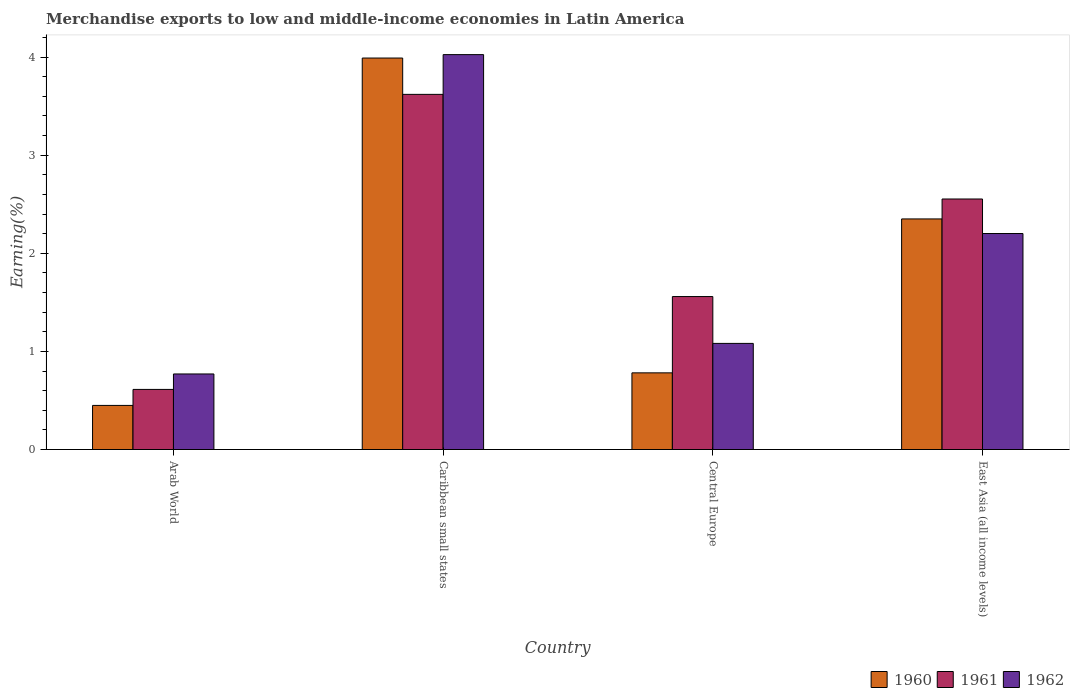How many groups of bars are there?
Keep it short and to the point. 4. Are the number of bars on each tick of the X-axis equal?
Provide a short and direct response. Yes. How many bars are there on the 3rd tick from the right?
Provide a short and direct response. 3. What is the label of the 2nd group of bars from the left?
Give a very brief answer. Caribbean small states. What is the percentage of amount earned from merchandise exports in 1962 in East Asia (all income levels)?
Keep it short and to the point. 2.2. Across all countries, what is the maximum percentage of amount earned from merchandise exports in 1961?
Make the answer very short. 3.62. Across all countries, what is the minimum percentage of amount earned from merchandise exports in 1962?
Provide a short and direct response. 0.77. In which country was the percentage of amount earned from merchandise exports in 1962 maximum?
Offer a terse response. Caribbean small states. In which country was the percentage of amount earned from merchandise exports in 1962 minimum?
Ensure brevity in your answer.  Arab World. What is the total percentage of amount earned from merchandise exports in 1960 in the graph?
Provide a short and direct response. 7.57. What is the difference between the percentage of amount earned from merchandise exports in 1960 in Central Europe and that in East Asia (all income levels)?
Keep it short and to the point. -1.57. What is the difference between the percentage of amount earned from merchandise exports in 1960 in Arab World and the percentage of amount earned from merchandise exports in 1962 in Central Europe?
Offer a very short reply. -0.63. What is the average percentage of amount earned from merchandise exports in 1961 per country?
Your response must be concise. 2.09. What is the difference between the percentage of amount earned from merchandise exports of/in 1961 and percentage of amount earned from merchandise exports of/in 1962 in Caribbean small states?
Offer a terse response. -0.41. What is the ratio of the percentage of amount earned from merchandise exports in 1962 in Arab World to that in East Asia (all income levels)?
Offer a very short reply. 0.35. Is the difference between the percentage of amount earned from merchandise exports in 1961 in Arab World and Central Europe greater than the difference between the percentage of amount earned from merchandise exports in 1962 in Arab World and Central Europe?
Offer a terse response. No. What is the difference between the highest and the second highest percentage of amount earned from merchandise exports in 1962?
Your answer should be compact. -1.12. What is the difference between the highest and the lowest percentage of amount earned from merchandise exports in 1961?
Provide a succinct answer. 3.01. What does the 1st bar from the left in Arab World represents?
Keep it short and to the point. 1960. Is it the case that in every country, the sum of the percentage of amount earned from merchandise exports in 1960 and percentage of amount earned from merchandise exports in 1961 is greater than the percentage of amount earned from merchandise exports in 1962?
Your response must be concise. Yes. How many bars are there?
Make the answer very short. 12. Are all the bars in the graph horizontal?
Provide a short and direct response. No. How many countries are there in the graph?
Your answer should be compact. 4. What is the difference between two consecutive major ticks on the Y-axis?
Offer a very short reply. 1. Are the values on the major ticks of Y-axis written in scientific E-notation?
Your response must be concise. No. Does the graph contain grids?
Provide a short and direct response. No. How many legend labels are there?
Make the answer very short. 3. How are the legend labels stacked?
Ensure brevity in your answer.  Horizontal. What is the title of the graph?
Ensure brevity in your answer.  Merchandise exports to low and middle-income economies in Latin America. What is the label or title of the Y-axis?
Your response must be concise. Earning(%). What is the Earning(%) of 1960 in Arab World?
Offer a very short reply. 0.45. What is the Earning(%) of 1961 in Arab World?
Offer a terse response. 0.61. What is the Earning(%) of 1962 in Arab World?
Offer a terse response. 0.77. What is the Earning(%) of 1960 in Caribbean small states?
Provide a short and direct response. 3.99. What is the Earning(%) in 1961 in Caribbean small states?
Provide a succinct answer. 3.62. What is the Earning(%) in 1962 in Caribbean small states?
Ensure brevity in your answer.  4.02. What is the Earning(%) in 1960 in Central Europe?
Your response must be concise. 0.78. What is the Earning(%) of 1961 in Central Europe?
Your answer should be compact. 1.56. What is the Earning(%) in 1962 in Central Europe?
Offer a very short reply. 1.08. What is the Earning(%) in 1960 in East Asia (all income levels)?
Make the answer very short. 2.35. What is the Earning(%) in 1961 in East Asia (all income levels)?
Offer a terse response. 2.55. What is the Earning(%) of 1962 in East Asia (all income levels)?
Your response must be concise. 2.2. Across all countries, what is the maximum Earning(%) of 1960?
Your answer should be compact. 3.99. Across all countries, what is the maximum Earning(%) in 1961?
Make the answer very short. 3.62. Across all countries, what is the maximum Earning(%) of 1962?
Your answer should be very brief. 4.02. Across all countries, what is the minimum Earning(%) of 1960?
Ensure brevity in your answer.  0.45. Across all countries, what is the minimum Earning(%) of 1961?
Offer a very short reply. 0.61. Across all countries, what is the minimum Earning(%) in 1962?
Your response must be concise. 0.77. What is the total Earning(%) in 1960 in the graph?
Provide a succinct answer. 7.57. What is the total Earning(%) in 1961 in the graph?
Make the answer very short. 8.34. What is the total Earning(%) of 1962 in the graph?
Your response must be concise. 8.08. What is the difference between the Earning(%) of 1960 in Arab World and that in Caribbean small states?
Offer a terse response. -3.54. What is the difference between the Earning(%) in 1961 in Arab World and that in Caribbean small states?
Make the answer very short. -3.01. What is the difference between the Earning(%) of 1962 in Arab World and that in Caribbean small states?
Ensure brevity in your answer.  -3.25. What is the difference between the Earning(%) in 1960 in Arab World and that in Central Europe?
Provide a short and direct response. -0.33. What is the difference between the Earning(%) of 1961 in Arab World and that in Central Europe?
Your response must be concise. -0.95. What is the difference between the Earning(%) in 1962 in Arab World and that in Central Europe?
Offer a terse response. -0.31. What is the difference between the Earning(%) in 1960 in Arab World and that in East Asia (all income levels)?
Provide a short and direct response. -1.9. What is the difference between the Earning(%) of 1961 in Arab World and that in East Asia (all income levels)?
Offer a terse response. -1.94. What is the difference between the Earning(%) of 1962 in Arab World and that in East Asia (all income levels)?
Your response must be concise. -1.43. What is the difference between the Earning(%) in 1960 in Caribbean small states and that in Central Europe?
Ensure brevity in your answer.  3.21. What is the difference between the Earning(%) of 1961 in Caribbean small states and that in Central Europe?
Make the answer very short. 2.06. What is the difference between the Earning(%) in 1962 in Caribbean small states and that in Central Europe?
Give a very brief answer. 2.94. What is the difference between the Earning(%) in 1960 in Caribbean small states and that in East Asia (all income levels)?
Give a very brief answer. 1.64. What is the difference between the Earning(%) of 1961 in Caribbean small states and that in East Asia (all income levels)?
Keep it short and to the point. 1.07. What is the difference between the Earning(%) in 1962 in Caribbean small states and that in East Asia (all income levels)?
Your answer should be compact. 1.82. What is the difference between the Earning(%) in 1960 in Central Europe and that in East Asia (all income levels)?
Make the answer very short. -1.57. What is the difference between the Earning(%) of 1961 in Central Europe and that in East Asia (all income levels)?
Keep it short and to the point. -0.99. What is the difference between the Earning(%) in 1962 in Central Europe and that in East Asia (all income levels)?
Make the answer very short. -1.12. What is the difference between the Earning(%) of 1960 in Arab World and the Earning(%) of 1961 in Caribbean small states?
Ensure brevity in your answer.  -3.17. What is the difference between the Earning(%) in 1960 in Arab World and the Earning(%) in 1962 in Caribbean small states?
Your response must be concise. -3.58. What is the difference between the Earning(%) of 1961 in Arab World and the Earning(%) of 1962 in Caribbean small states?
Offer a terse response. -3.41. What is the difference between the Earning(%) in 1960 in Arab World and the Earning(%) in 1961 in Central Europe?
Offer a terse response. -1.11. What is the difference between the Earning(%) of 1960 in Arab World and the Earning(%) of 1962 in Central Europe?
Keep it short and to the point. -0.63. What is the difference between the Earning(%) in 1961 in Arab World and the Earning(%) in 1962 in Central Europe?
Give a very brief answer. -0.47. What is the difference between the Earning(%) in 1960 in Arab World and the Earning(%) in 1961 in East Asia (all income levels)?
Offer a very short reply. -2.1. What is the difference between the Earning(%) of 1960 in Arab World and the Earning(%) of 1962 in East Asia (all income levels)?
Keep it short and to the point. -1.75. What is the difference between the Earning(%) in 1961 in Arab World and the Earning(%) in 1962 in East Asia (all income levels)?
Provide a succinct answer. -1.59. What is the difference between the Earning(%) of 1960 in Caribbean small states and the Earning(%) of 1961 in Central Europe?
Provide a succinct answer. 2.43. What is the difference between the Earning(%) in 1960 in Caribbean small states and the Earning(%) in 1962 in Central Europe?
Offer a terse response. 2.91. What is the difference between the Earning(%) in 1961 in Caribbean small states and the Earning(%) in 1962 in Central Europe?
Give a very brief answer. 2.54. What is the difference between the Earning(%) in 1960 in Caribbean small states and the Earning(%) in 1961 in East Asia (all income levels)?
Ensure brevity in your answer.  1.44. What is the difference between the Earning(%) in 1960 in Caribbean small states and the Earning(%) in 1962 in East Asia (all income levels)?
Your response must be concise. 1.79. What is the difference between the Earning(%) of 1961 in Caribbean small states and the Earning(%) of 1962 in East Asia (all income levels)?
Offer a terse response. 1.42. What is the difference between the Earning(%) in 1960 in Central Europe and the Earning(%) in 1961 in East Asia (all income levels)?
Offer a terse response. -1.77. What is the difference between the Earning(%) in 1960 in Central Europe and the Earning(%) in 1962 in East Asia (all income levels)?
Your answer should be very brief. -1.42. What is the difference between the Earning(%) of 1961 in Central Europe and the Earning(%) of 1962 in East Asia (all income levels)?
Keep it short and to the point. -0.64. What is the average Earning(%) of 1960 per country?
Make the answer very short. 1.89. What is the average Earning(%) of 1961 per country?
Provide a succinct answer. 2.09. What is the average Earning(%) in 1962 per country?
Offer a very short reply. 2.02. What is the difference between the Earning(%) of 1960 and Earning(%) of 1961 in Arab World?
Ensure brevity in your answer.  -0.16. What is the difference between the Earning(%) of 1960 and Earning(%) of 1962 in Arab World?
Offer a terse response. -0.32. What is the difference between the Earning(%) of 1961 and Earning(%) of 1962 in Arab World?
Your response must be concise. -0.16. What is the difference between the Earning(%) in 1960 and Earning(%) in 1961 in Caribbean small states?
Provide a short and direct response. 0.37. What is the difference between the Earning(%) of 1960 and Earning(%) of 1962 in Caribbean small states?
Keep it short and to the point. -0.03. What is the difference between the Earning(%) of 1961 and Earning(%) of 1962 in Caribbean small states?
Offer a very short reply. -0.41. What is the difference between the Earning(%) of 1960 and Earning(%) of 1961 in Central Europe?
Provide a succinct answer. -0.78. What is the difference between the Earning(%) in 1960 and Earning(%) in 1962 in Central Europe?
Your response must be concise. -0.3. What is the difference between the Earning(%) in 1961 and Earning(%) in 1962 in Central Europe?
Give a very brief answer. 0.48. What is the difference between the Earning(%) in 1960 and Earning(%) in 1961 in East Asia (all income levels)?
Your answer should be very brief. -0.2. What is the difference between the Earning(%) of 1960 and Earning(%) of 1962 in East Asia (all income levels)?
Your response must be concise. 0.15. What is the difference between the Earning(%) in 1961 and Earning(%) in 1962 in East Asia (all income levels)?
Make the answer very short. 0.35. What is the ratio of the Earning(%) in 1960 in Arab World to that in Caribbean small states?
Give a very brief answer. 0.11. What is the ratio of the Earning(%) in 1961 in Arab World to that in Caribbean small states?
Your answer should be very brief. 0.17. What is the ratio of the Earning(%) of 1962 in Arab World to that in Caribbean small states?
Your response must be concise. 0.19. What is the ratio of the Earning(%) in 1960 in Arab World to that in Central Europe?
Your answer should be compact. 0.58. What is the ratio of the Earning(%) of 1961 in Arab World to that in Central Europe?
Provide a succinct answer. 0.39. What is the ratio of the Earning(%) in 1962 in Arab World to that in Central Europe?
Keep it short and to the point. 0.71. What is the ratio of the Earning(%) in 1960 in Arab World to that in East Asia (all income levels)?
Your answer should be very brief. 0.19. What is the ratio of the Earning(%) in 1961 in Arab World to that in East Asia (all income levels)?
Provide a succinct answer. 0.24. What is the ratio of the Earning(%) of 1962 in Arab World to that in East Asia (all income levels)?
Your answer should be very brief. 0.35. What is the ratio of the Earning(%) in 1960 in Caribbean small states to that in Central Europe?
Make the answer very short. 5.11. What is the ratio of the Earning(%) in 1961 in Caribbean small states to that in Central Europe?
Your answer should be very brief. 2.32. What is the ratio of the Earning(%) of 1962 in Caribbean small states to that in Central Europe?
Keep it short and to the point. 3.72. What is the ratio of the Earning(%) of 1960 in Caribbean small states to that in East Asia (all income levels)?
Give a very brief answer. 1.7. What is the ratio of the Earning(%) of 1961 in Caribbean small states to that in East Asia (all income levels)?
Your answer should be very brief. 1.42. What is the ratio of the Earning(%) in 1962 in Caribbean small states to that in East Asia (all income levels)?
Provide a short and direct response. 1.83. What is the ratio of the Earning(%) in 1960 in Central Europe to that in East Asia (all income levels)?
Give a very brief answer. 0.33. What is the ratio of the Earning(%) of 1961 in Central Europe to that in East Asia (all income levels)?
Make the answer very short. 0.61. What is the ratio of the Earning(%) in 1962 in Central Europe to that in East Asia (all income levels)?
Ensure brevity in your answer.  0.49. What is the difference between the highest and the second highest Earning(%) in 1960?
Your response must be concise. 1.64. What is the difference between the highest and the second highest Earning(%) of 1961?
Offer a very short reply. 1.07. What is the difference between the highest and the second highest Earning(%) in 1962?
Provide a succinct answer. 1.82. What is the difference between the highest and the lowest Earning(%) of 1960?
Your response must be concise. 3.54. What is the difference between the highest and the lowest Earning(%) in 1961?
Give a very brief answer. 3.01. What is the difference between the highest and the lowest Earning(%) of 1962?
Your answer should be very brief. 3.25. 